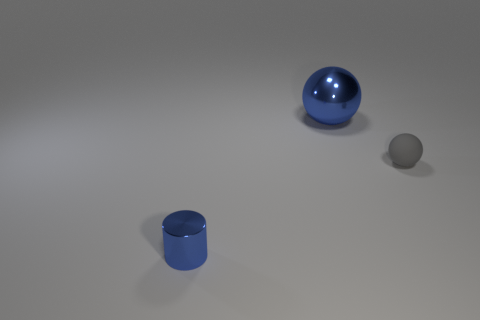Are there any big spheres behind the blue metallic object that is in front of the blue thing to the right of the cylinder?
Your response must be concise. Yes. Is the gray object the same size as the blue sphere?
Give a very brief answer. No. Is the number of big blue metallic balls right of the tiny blue metal thing the same as the number of blue metallic cylinders that are in front of the big blue object?
Your answer should be very brief. Yes. The shiny object behind the blue metal cylinder has what shape?
Your response must be concise. Sphere. What is the shape of the blue shiny object that is the same size as the rubber thing?
Offer a very short reply. Cylinder. What color is the tiny object left of the small ball that is behind the metal object on the left side of the big blue metal ball?
Make the answer very short. Blue. Is the small gray matte object the same shape as the small blue object?
Your answer should be very brief. No. Is the number of large metal objects that are to the right of the tiny cylinder the same as the number of big metal spheres?
Provide a succinct answer. Yes. What number of other things are there of the same material as the tiny blue cylinder
Make the answer very short. 1. Does the shiny thing that is to the right of the shiny cylinder have the same size as the thing on the left side of the blue sphere?
Ensure brevity in your answer.  No. 